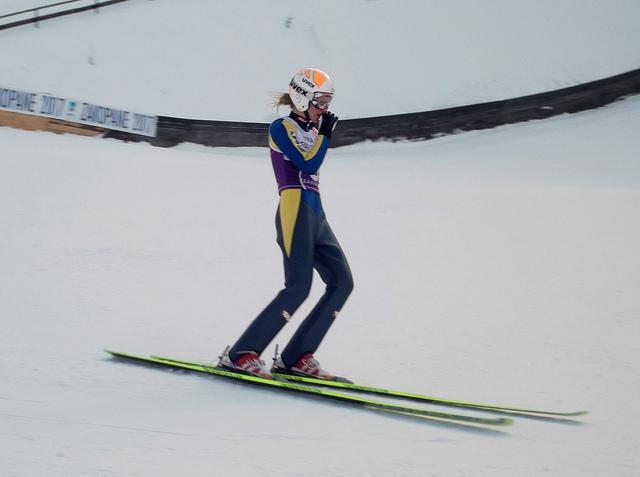What is on this person's head?
Give a very brief answer. Helmet. What color are the skis?
Short answer required. Green. Does the woman appear to be holding ski poles?
Answer briefly. No. 